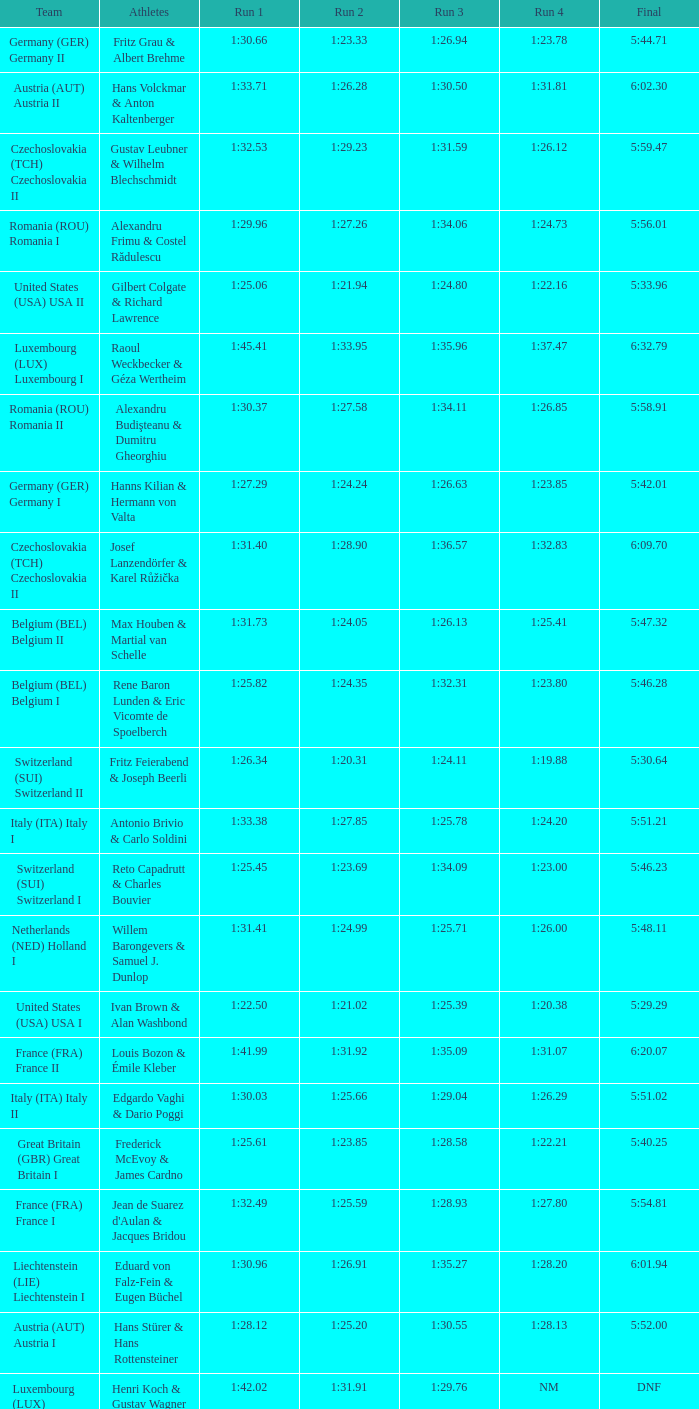Give me the full table as a dictionary. {'header': ['Team', 'Athletes', 'Run 1', 'Run 2', 'Run 3', 'Run 4', 'Final'], 'rows': [['Germany (GER) Germany II', 'Fritz Grau & Albert Brehme', '1:30.66', '1:23.33', '1:26.94', '1:23.78', '5:44.71'], ['Austria (AUT) Austria II', 'Hans Volckmar & Anton Kaltenberger', '1:33.71', '1:26.28', '1:30.50', '1:31.81', '6:02.30'], ['Czechoslovakia (TCH) Czechoslovakia II', 'Gustav Leubner & Wilhelm Blechschmidt', '1:32.53', '1:29.23', '1:31.59', '1:26.12', '5:59.47'], ['Romania (ROU) Romania I', 'Alexandru Frimu & Costel Rădulescu', '1:29.96', '1:27.26', '1:34.06', '1:24.73', '5:56.01'], ['United States (USA) USA II', 'Gilbert Colgate & Richard Lawrence', '1:25.06', '1:21.94', '1:24.80', '1:22.16', '5:33.96'], ['Luxembourg (LUX) Luxembourg I', 'Raoul Weckbecker & Géza Wertheim', '1:45.41', '1:33.95', '1:35.96', '1:37.47', '6:32.79'], ['Romania (ROU) Romania II', 'Alexandru Budişteanu & Dumitru Gheorghiu', '1:30.37', '1:27.58', '1:34.11', '1:26.85', '5:58.91'], ['Germany (GER) Germany I', 'Hanns Kilian & Hermann von Valta', '1:27.29', '1:24.24', '1:26.63', '1:23.85', '5:42.01'], ['Czechoslovakia (TCH) Czechoslovakia II', 'Josef Lanzendörfer & Karel Růžička', '1:31.40', '1:28.90', '1:36.57', '1:32.83', '6:09.70'], ['Belgium (BEL) Belgium II', 'Max Houben & Martial van Schelle', '1:31.73', '1:24.05', '1:26.13', '1:25.41', '5:47.32'], ['Belgium (BEL) Belgium I', 'Rene Baron Lunden & Eric Vicomte de Spoelberch', '1:25.82', '1:24.35', '1:32.31', '1:23.80', '5:46.28'], ['Switzerland (SUI) Switzerland II', 'Fritz Feierabend & Joseph Beerli', '1:26.34', '1:20.31', '1:24.11', '1:19.88', '5:30.64'], ['Italy (ITA) Italy I', 'Antonio Brivio & Carlo Soldini', '1:33.38', '1:27.85', '1:25.78', '1:24.20', '5:51.21'], ['Switzerland (SUI) Switzerland I', 'Reto Capadrutt & Charles Bouvier', '1:25.45', '1:23.69', '1:34.09', '1:23.00', '5:46.23'], ['Netherlands (NED) Holland I', 'Willem Barongevers & Samuel J. Dunlop', '1:31.41', '1:24.99', '1:25.71', '1:26.00', '5:48.11'], ['United States (USA) USA I', 'Ivan Brown & Alan Washbond', '1:22.50', '1:21.02', '1:25.39', '1:20.38', '5:29.29'], ['France (FRA) France II', 'Louis Bozon & Émile Kleber', '1:41.99', '1:31.92', '1:35.09', '1:31.07', '6:20.07'], ['Italy (ITA) Italy II', 'Edgardo Vaghi & Dario Poggi', '1:30.03', '1:25.66', '1:29.04', '1:26.29', '5:51.02'], ['Great Britain (GBR) Great Britain I', 'Frederick McEvoy & James Cardno', '1:25.61', '1:23.85', '1:28.58', '1:22.21', '5:40.25'], ['France (FRA) France I', "Jean de Suarez d'Aulan & Jacques Bridou", '1:32.49', '1:25.59', '1:28.93', '1:27.80', '5:54.81'], ['Liechtenstein (LIE) Liechtenstein I', 'Eduard von Falz-Fein & Eugen Büchel', '1:30.96', '1:26.91', '1:35.27', '1:28.20', '6:01.94'], ['Austria (AUT) Austria I', 'Hans Stürer & Hans Rottensteiner', '1:28.12', '1:25.20', '1:30.55', '1:28.13', '5:52.00'], ['Luxembourg (LUX) Luxembourg II', 'Henri Koch & Gustav Wagner', '1:42.02', '1:31.91', '1:29.76', 'NM', 'DNF']]} Which Run 4 has a Run 1 of 1:25.82? 1:23.80. 